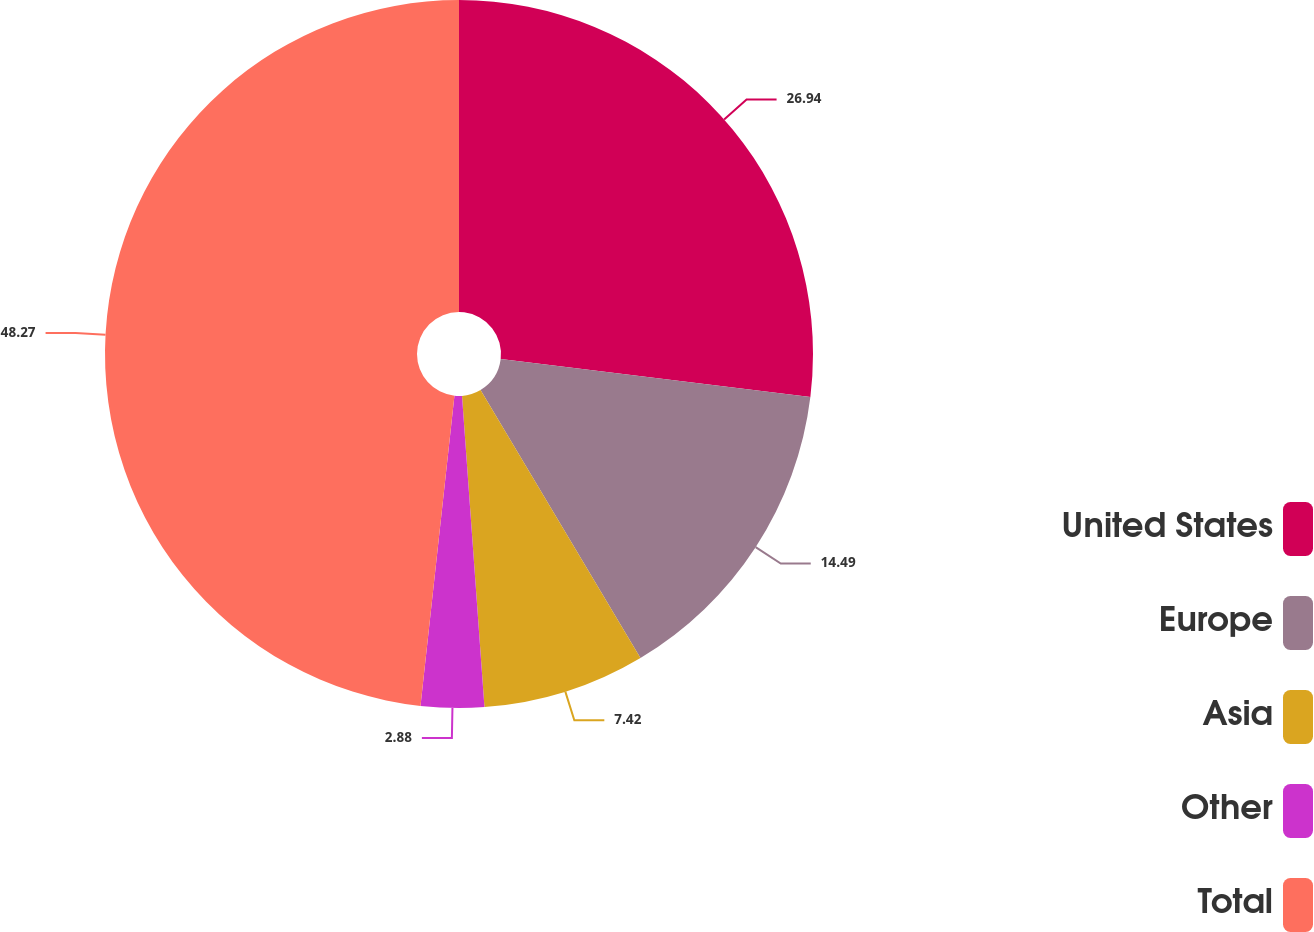<chart> <loc_0><loc_0><loc_500><loc_500><pie_chart><fcel>United States<fcel>Europe<fcel>Asia<fcel>Other<fcel>Total<nl><fcel>26.94%<fcel>14.49%<fcel>7.42%<fcel>2.88%<fcel>48.26%<nl></chart> 